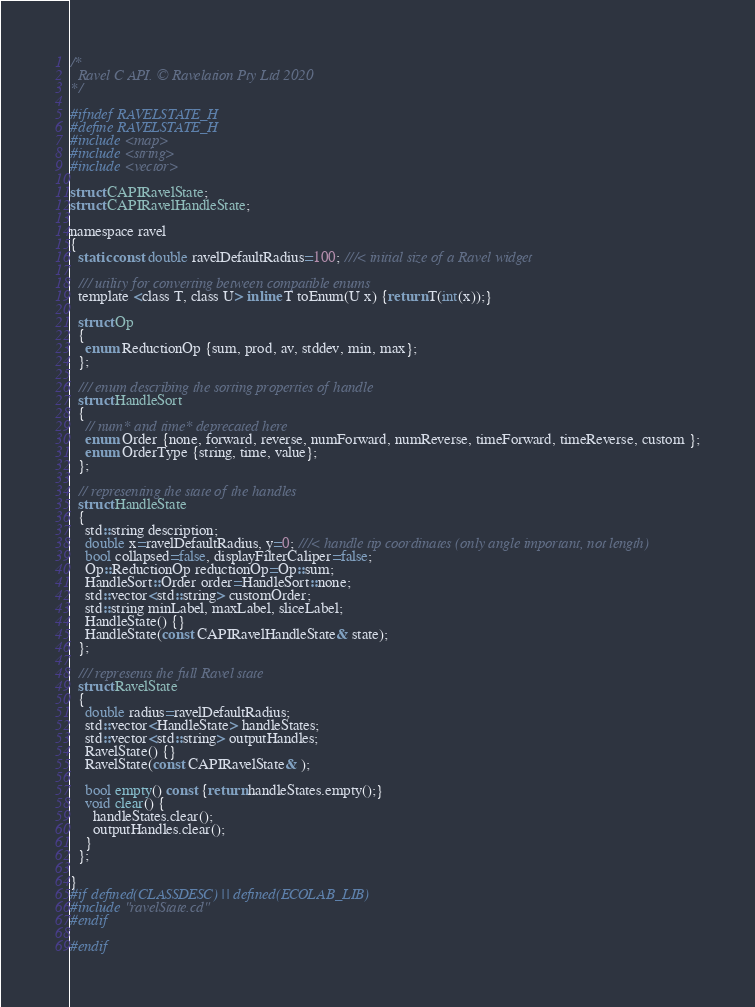<code> <loc_0><loc_0><loc_500><loc_500><_C_>/*
  Ravel C API. © Ravelation Pty Ltd 2020
*/

#ifndef RAVELSTATE_H
#define RAVELSTATE_H
#include <map>
#include <string>
#include <vector>

struct CAPIRavelState;
struct CAPIRavelHandleState;

namespace ravel
{
  static const double ravelDefaultRadius=100; ///< initial size of a Ravel widget

  /// utility for converting between compatible enums
  template <class T, class U> inline T toEnum(U x) {return T(int(x));}

  struct Op
  {
    enum ReductionOp {sum, prod, av, stddev, min, max};
  };

  /// enum describing the sorting properties of handle
  struct HandleSort
  {
    // num* and time* deprecated here
    enum Order {none, forward, reverse, numForward, numReverse, timeForward, timeReverse, custom };
    enum OrderType {string, time, value};
  };

  // representing the state of the handles
  struct HandleState
  {
    std::string description;
    double x=ravelDefaultRadius, y=0; ///< handle tip coordinates (only angle important, not length)
    bool collapsed=false, displayFilterCaliper=false;
    Op::ReductionOp reductionOp=Op::sum;
    HandleSort::Order order=HandleSort::none;
    std::vector<std::string> customOrder; 
    std::string minLabel, maxLabel, sliceLabel;
    HandleState() {}
    HandleState(const CAPIRavelHandleState& state);
  };

  /// represents the full Ravel state
  struct RavelState
  {
    double radius=ravelDefaultRadius;
    std::vector<HandleState> handleStates;
    std::vector<std::string> outputHandles;
    RavelState() {}
    RavelState(const CAPIRavelState& );
      
    bool empty() const {return handleStates.empty();}
    void clear() {
      handleStates.clear();
      outputHandles.clear();
    }
  };
  
}
#if defined(CLASSDESC) || defined(ECOLAB_LIB)
#include "ravelState.cd"
#endif

#endif
</code> 